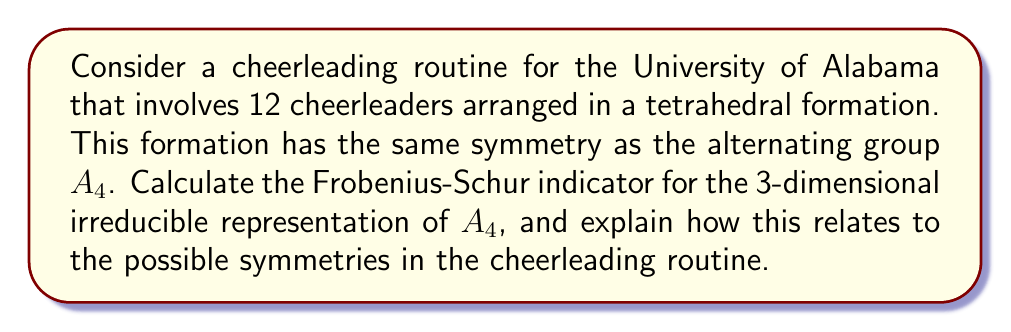Give your solution to this math problem. Let's approach this step-by-step:

1) First, recall that the Frobenius-Schur indicator $\nu(\chi)$ for a character $\chi$ of a finite group $G$ is given by:

   $$\nu(\chi) = \frac{1}{|G|} \sum_{g \in G} \chi(g^2)$$

2) For $A_4$, we have $|G| = 12$.

3) The character table of $A_4$ is:

   $$\begin{array}{c|cccc}
      & 1 & (12)(34) & (123) & (132) \\
   \hline
   \chi_1 & 1 & 1 & 1 & 1 \\
   \chi_2 & 1 & 1 & \omega & \omega^2 \\
   \chi_3 & 1 & 1 & \omega^2 & \omega \\
   \chi_4 & 3 & -1 & 0 & 0
   \end{array}$$

   where $\omega = e^{2\pi i/3}$ is a primitive cube root of unity.

4) We're interested in $\chi_4$, the 3-dimensional irreducible representation.

5) To calculate $\nu(\chi_4)$, we need to sum $\chi_4(g^2)$ for all $g \in A_4$:
   - For the identity: $\chi_4(1^2) = \chi_4(1) = 3$
   - For $(12)(34)$: $\chi_4((12)(34)^2) = \chi_4(1) = 3$
   - For $(123)$: $\chi_4((123)^2) = \chi_4((132)) = 0$
   - For $(132)$: $\chi_4((132)^2) = \chi_4((123)) = 0$

6) There are 1 element of order 1, 3 elements of order 2, and 8 elements of order 3 in $A_4$.

7) Therefore:

   $$\nu(\chi_4) = \frac{1}{12}(3 + 3 \cdot 3 + 8 \cdot 0) = 1$$

8) The Frobenius-Schur indicator being 1 indicates that this representation is real.

9) In terms of the cheerleading routine, this means that all symmetries in the tetrahedral formation can be realized by actual physical movements of the cheerleaders, without needing complex number rotations.
Answer: $\nu(\chi_4) = 1$ 